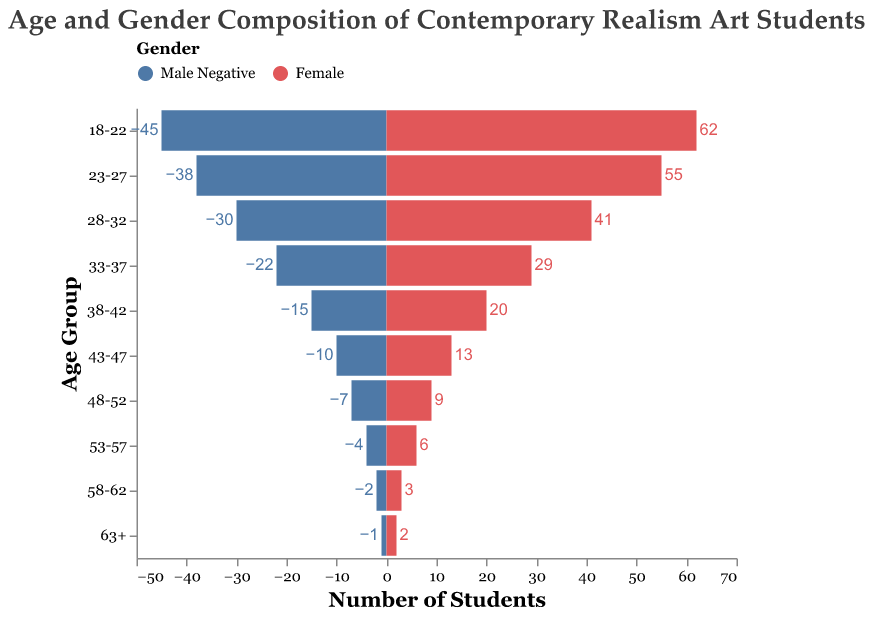What's the title of the chart? The title is found at the top of the chart in a prominent font. It reads "Age and Gender Composition of Contemporary Realism Art Students".
Answer: Age and Gender Composition of Contemporary Realism Art Students How many students are in the 18-22 age group? To find this, look at the combined values for the Male and Female categories within the 18-22 age group. The data shows 45 males and 62 females, so the total is 45 + 62.
Answer: 107 Which age group has the highest number of female students? Check the female values across different age groups. The highest number is in the 18-22 age group with 62 female students.
Answer: 18-22 How many more male students are in the 18-22 age group compared to the 33-37 age group? Subtract the number of males in the 33-37 age group (22) from the number of males in the 18-22 age group (45).
Answer: 23 What's the proportion of male students to female students in the 23-27 age group? Calculate the ratio of males to females in the 23-27 age group, which is 38 males to 55 females. Simplify if possible. The ratio is 38/55 or approximately 0.69.
Answer: 0.69 Which age group has the smallest overall student population? Review the sum of Male and Female students across all age groups. The smallest population appears in the 63+ age group with 3 students (1 male and 2 females).
Answer: 63+ Is there any age group where the number of male students is exactly half the number of female students? Check each age group to see if the male count is half the female count. In the 18-22 age group, 45 males and 62 females don't satisfy this. In the 23-27, 38 males and 55 females don't as well. Each needs checking likewise, no age group matches this.
Answer: No What is the total number of students aged 33-47? Add up the values of male and female students in the 33-37 and 38-42 and 43-47 groups: (22+29)+(15+20)+(10+13) = 99 students.
Answer: 99 Which gender has a more pronounced presence in the older age brackets (48-62+)? Summarize the female and male students from age groups 48-52, 53-57, 58-62, and 63+. Females total (9+6+3+2) = 20 and males (7+4+2+1) = 14. Females have a more pronounced presence.
Answer: Female Between the 28-32 and 33-37 age groups, which has a higher percentage of female students? For each group, calculate the percentage of females. In 28-32: 41/(30+41) ≈ 0.577 or 57.7%, and in 33-37: 29/(22+29) ≈ 0.569 or 56.9%. The 28-32 age group has a higher percentage of females.
Answer: 28-32 